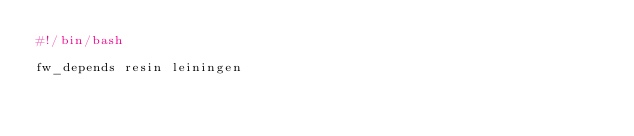Convert code to text. <code><loc_0><loc_0><loc_500><loc_500><_Bash_>#!/bin/bash

fw_depends resin leiningen
</code> 